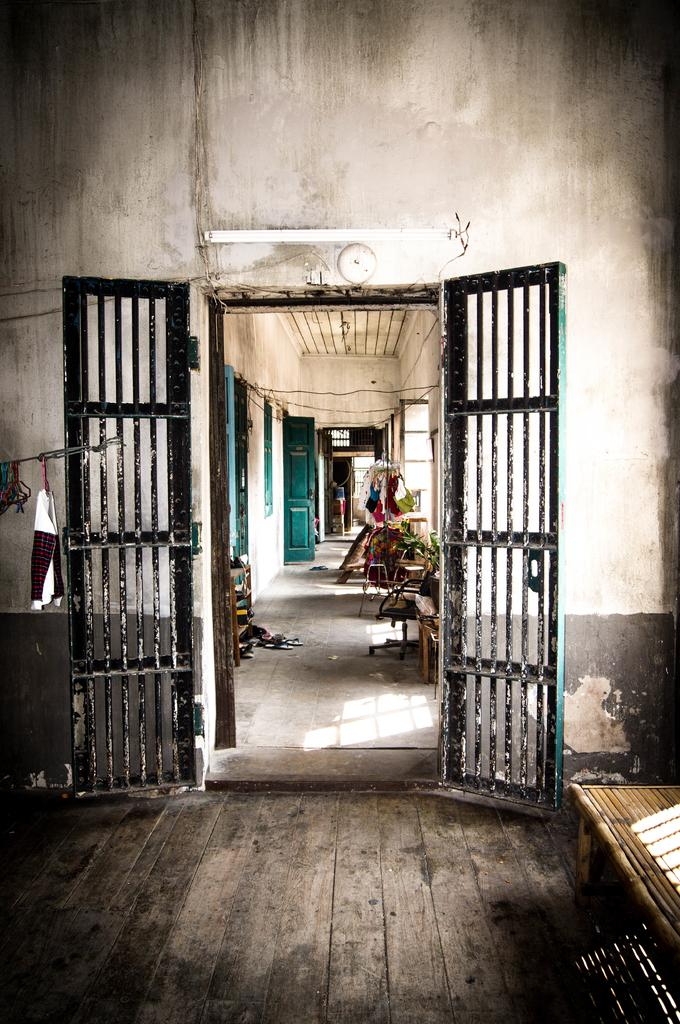What can be observed about the image in terms of editing? The image is edited. What is one of the main features visible in the image? There is a door in the image. What is located behind the door? Inside the door, there are many houses in a compartment. What color are the doors of the houses? The doors of the houses are in green color. What position does the mother hold in the image? There is no mother present in the image. What type of apparatus is used to open the door in the image? The image does not show any apparatus used to open the door; it only shows the door and the houses behind it. 